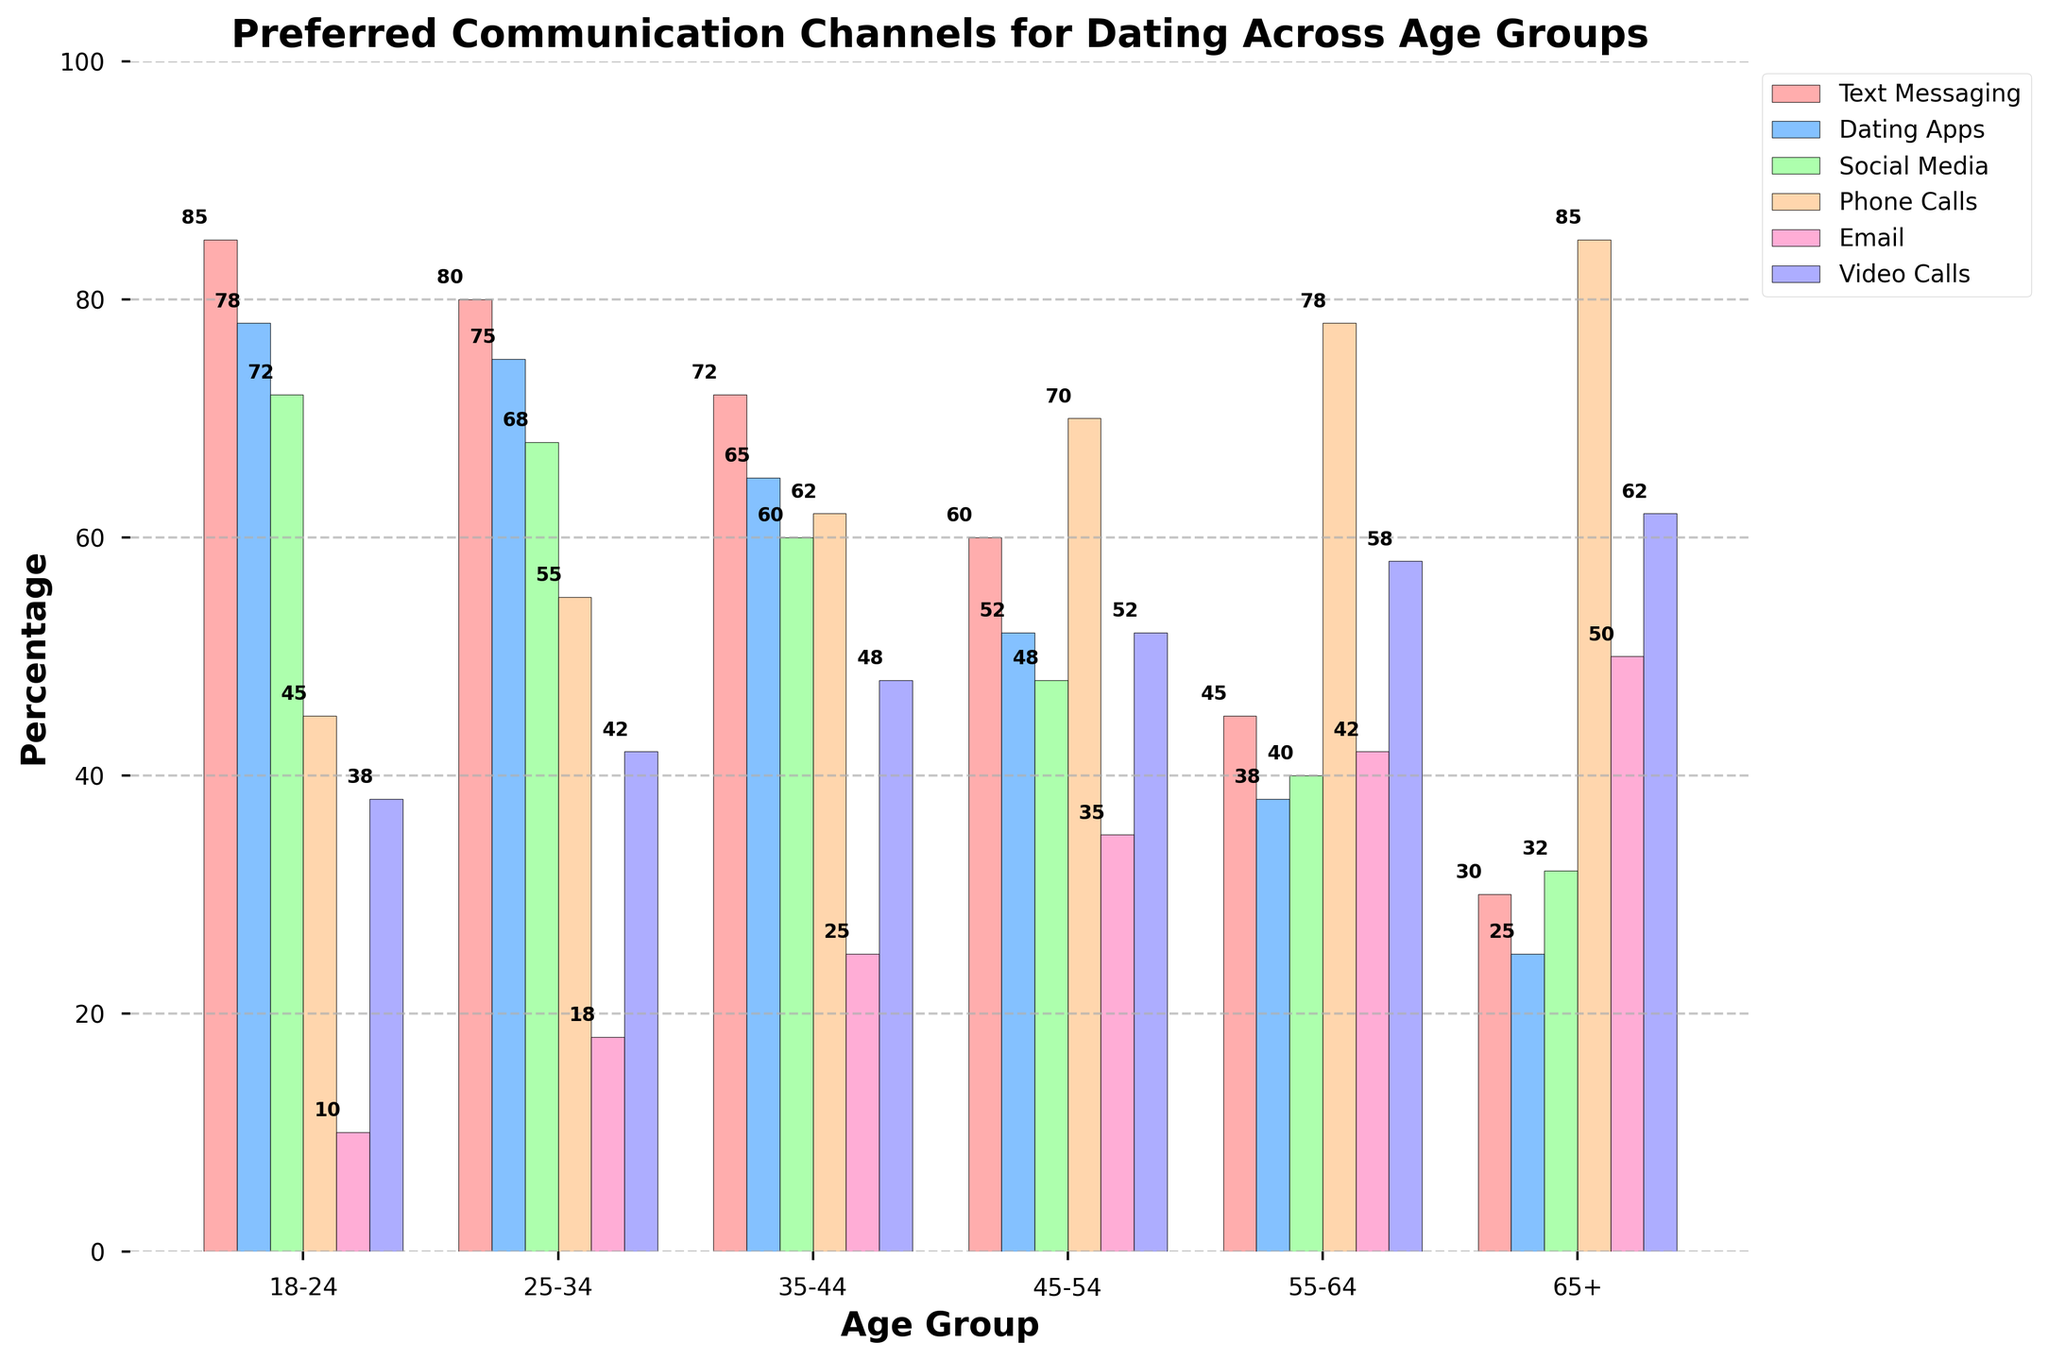Which age group prefers texting the most? By visually examining the bar chart, we can observe that the 18-24 age group has the tallest bar for Text Messaging, indicating the highest percentage.
Answer: 18-24 Which two age groups have the least preference for dating apps and how do their percentages compare? The smallest bars in the Dating Apps category are for the 65+ and 55-64 age groups. The 65+ group has a preference of 25%, while the 55-64 group has a preference of 38%.
Answer: 65+ has 25%, 55-64 has 38% What is the sum of the preferred percentages for video calls across age groups 18-24 and 25-34? By looking at the bar chart, the percentage for video calls for the 18-24 age group is 38% and for the 25-34 age group is 42%. The sum is 38 + 42 = 80%.
Answer: 80% Which age group has the highest preference for phone calls, and what is that percentage? The tallest bar in the Phone Calls category is for the 65+ age group, indicating a preference of 85%.
Answer: 65+, 85% How do the preferences for email communication change as the age group increases from 18-24 to 65+? Observing the bar heights for Email, they gradually increase: 18-24 (10%), 25-34 (18%), 35-44 (25%), 45-54 (35%), 55-64 (42%), to 65+ (50%). The preference percentage increases with age.
Answer: Increase from 10% to 50% Compare the preferences for social media between the 25-34 and 45-54 age groups. By examining the bars in the Social Media category, the 25-34 age group has a preference of 68%, while the 45-54 age group has a preference of 48%.
Answer: 25-34 has 68%, 45-54 has 48% What is the average preference percentage for Email across all age groups? The percentages for Email across all age groups are 10%, 18%, 25%, 35%, 42%, and 50%. Summing these gives 10 + 18 + 25 + 35 + 42 + 50 = 180. Dividing by 6 (number of age groups) gives an average of 180 / 6 = 30%.
Answer: 30% Which communication channel sees the sharpest decline in preference as age increases from 18-24 to 65+? By comparing the bar heights across age groups, Text Messaging starts at 85% for the 18-24 age group and decreases to 30% for the 65+ age group. This represents the sharpest decline (85% - 30% = 55%).
Answer: Text Messaging 